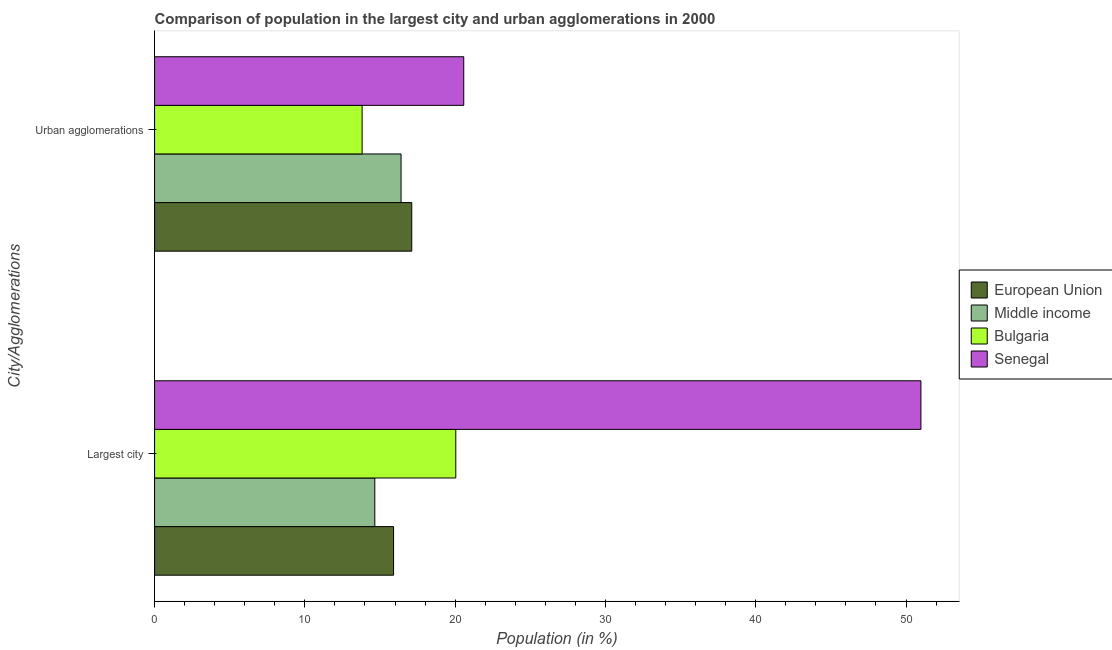How many groups of bars are there?
Make the answer very short. 2. Are the number of bars on each tick of the Y-axis equal?
Provide a short and direct response. Yes. How many bars are there on the 1st tick from the bottom?
Make the answer very short. 4. What is the label of the 2nd group of bars from the top?
Keep it short and to the point. Largest city. What is the population in the largest city in Senegal?
Provide a short and direct response. 50.99. Across all countries, what is the maximum population in the largest city?
Offer a very short reply. 50.99. Across all countries, what is the minimum population in urban agglomerations?
Provide a succinct answer. 13.81. In which country was the population in the largest city maximum?
Your answer should be compact. Senegal. In which country was the population in urban agglomerations minimum?
Give a very brief answer. Bulgaria. What is the total population in urban agglomerations in the graph?
Make the answer very short. 67.89. What is the difference between the population in urban agglomerations in Middle income and that in Bulgaria?
Give a very brief answer. 2.59. What is the difference between the population in the largest city in Middle income and the population in urban agglomerations in European Union?
Your response must be concise. -2.46. What is the average population in the largest city per country?
Make the answer very short. 25.4. What is the difference between the population in urban agglomerations and population in the largest city in Middle income?
Make the answer very short. 1.75. In how many countries, is the population in urban agglomerations greater than 34 %?
Keep it short and to the point. 0. What is the ratio of the population in the largest city in European Union to that in Middle income?
Give a very brief answer. 1.09. In how many countries, is the population in urban agglomerations greater than the average population in urban agglomerations taken over all countries?
Provide a succinct answer. 2. What does the 4th bar from the top in Largest city represents?
Offer a very short reply. European Union. What does the 1st bar from the bottom in Urban agglomerations represents?
Keep it short and to the point. European Union. How many bars are there?
Your answer should be compact. 8. How many countries are there in the graph?
Provide a short and direct response. 4. What is the difference between two consecutive major ticks on the X-axis?
Your answer should be very brief. 10. Does the graph contain any zero values?
Ensure brevity in your answer.  No. Where does the legend appear in the graph?
Give a very brief answer. Center right. How many legend labels are there?
Offer a very short reply. 4. How are the legend labels stacked?
Your answer should be very brief. Vertical. What is the title of the graph?
Your response must be concise. Comparison of population in the largest city and urban agglomerations in 2000. Does "French Polynesia" appear as one of the legend labels in the graph?
Ensure brevity in your answer.  No. What is the label or title of the Y-axis?
Offer a terse response. City/Agglomerations. What is the Population (in %) of European Union in Largest city?
Ensure brevity in your answer.  15.9. What is the Population (in %) of Middle income in Largest city?
Keep it short and to the point. 14.65. What is the Population (in %) in Bulgaria in Largest city?
Offer a very short reply. 20.04. What is the Population (in %) of Senegal in Largest city?
Provide a short and direct response. 50.99. What is the Population (in %) of European Union in Urban agglomerations?
Your answer should be very brief. 17.11. What is the Population (in %) in Middle income in Urban agglomerations?
Provide a short and direct response. 16.4. What is the Population (in %) of Bulgaria in Urban agglomerations?
Provide a short and direct response. 13.81. What is the Population (in %) in Senegal in Urban agglomerations?
Provide a short and direct response. 20.57. Across all City/Agglomerations, what is the maximum Population (in %) in European Union?
Ensure brevity in your answer.  17.11. Across all City/Agglomerations, what is the maximum Population (in %) in Middle income?
Provide a short and direct response. 16.4. Across all City/Agglomerations, what is the maximum Population (in %) in Bulgaria?
Give a very brief answer. 20.04. Across all City/Agglomerations, what is the maximum Population (in %) in Senegal?
Your response must be concise. 50.99. Across all City/Agglomerations, what is the minimum Population (in %) of European Union?
Offer a very short reply. 15.9. Across all City/Agglomerations, what is the minimum Population (in %) in Middle income?
Offer a terse response. 14.65. Across all City/Agglomerations, what is the minimum Population (in %) of Bulgaria?
Provide a short and direct response. 13.81. Across all City/Agglomerations, what is the minimum Population (in %) of Senegal?
Your response must be concise. 20.57. What is the total Population (in %) of European Union in the graph?
Provide a short and direct response. 33.02. What is the total Population (in %) of Middle income in the graph?
Make the answer very short. 31.06. What is the total Population (in %) of Bulgaria in the graph?
Your response must be concise. 33.85. What is the total Population (in %) in Senegal in the graph?
Give a very brief answer. 71.56. What is the difference between the Population (in %) in European Union in Largest city and that in Urban agglomerations?
Your answer should be compact. -1.21. What is the difference between the Population (in %) of Middle income in Largest city and that in Urban agglomerations?
Give a very brief answer. -1.75. What is the difference between the Population (in %) in Bulgaria in Largest city and that in Urban agglomerations?
Make the answer very short. 6.23. What is the difference between the Population (in %) of Senegal in Largest city and that in Urban agglomerations?
Keep it short and to the point. 30.42. What is the difference between the Population (in %) in European Union in Largest city and the Population (in %) in Middle income in Urban agglomerations?
Provide a short and direct response. -0.5. What is the difference between the Population (in %) of European Union in Largest city and the Population (in %) of Bulgaria in Urban agglomerations?
Keep it short and to the point. 2.09. What is the difference between the Population (in %) in European Union in Largest city and the Population (in %) in Senegal in Urban agglomerations?
Your answer should be very brief. -4.67. What is the difference between the Population (in %) in Middle income in Largest city and the Population (in %) in Bulgaria in Urban agglomerations?
Your response must be concise. 0.85. What is the difference between the Population (in %) in Middle income in Largest city and the Population (in %) in Senegal in Urban agglomerations?
Give a very brief answer. -5.92. What is the difference between the Population (in %) of Bulgaria in Largest city and the Population (in %) of Senegal in Urban agglomerations?
Provide a short and direct response. -0.53. What is the average Population (in %) of European Union per City/Agglomerations?
Provide a short and direct response. 16.51. What is the average Population (in %) in Middle income per City/Agglomerations?
Your response must be concise. 15.53. What is the average Population (in %) in Bulgaria per City/Agglomerations?
Your response must be concise. 16.93. What is the average Population (in %) of Senegal per City/Agglomerations?
Your answer should be compact. 35.78. What is the difference between the Population (in %) of European Union and Population (in %) of Middle income in Largest city?
Your answer should be very brief. 1.25. What is the difference between the Population (in %) of European Union and Population (in %) of Bulgaria in Largest city?
Give a very brief answer. -4.14. What is the difference between the Population (in %) of European Union and Population (in %) of Senegal in Largest city?
Provide a succinct answer. -35.09. What is the difference between the Population (in %) in Middle income and Population (in %) in Bulgaria in Largest city?
Provide a succinct answer. -5.39. What is the difference between the Population (in %) in Middle income and Population (in %) in Senegal in Largest city?
Make the answer very short. -36.34. What is the difference between the Population (in %) in Bulgaria and Population (in %) in Senegal in Largest city?
Offer a very short reply. -30.95. What is the difference between the Population (in %) in European Union and Population (in %) in Middle income in Urban agglomerations?
Make the answer very short. 0.71. What is the difference between the Population (in %) of European Union and Population (in %) of Bulgaria in Urban agglomerations?
Your response must be concise. 3.3. What is the difference between the Population (in %) of European Union and Population (in %) of Senegal in Urban agglomerations?
Offer a very short reply. -3.46. What is the difference between the Population (in %) of Middle income and Population (in %) of Bulgaria in Urban agglomerations?
Give a very brief answer. 2.59. What is the difference between the Population (in %) of Middle income and Population (in %) of Senegal in Urban agglomerations?
Keep it short and to the point. -4.17. What is the difference between the Population (in %) in Bulgaria and Population (in %) in Senegal in Urban agglomerations?
Offer a terse response. -6.76. What is the ratio of the Population (in %) of European Union in Largest city to that in Urban agglomerations?
Ensure brevity in your answer.  0.93. What is the ratio of the Population (in %) of Middle income in Largest city to that in Urban agglomerations?
Ensure brevity in your answer.  0.89. What is the ratio of the Population (in %) of Bulgaria in Largest city to that in Urban agglomerations?
Your answer should be very brief. 1.45. What is the ratio of the Population (in %) of Senegal in Largest city to that in Urban agglomerations?
Offer a terse response. 2.48. What is the difference between the highest and the second highest Population (in %) in European Union?
Offer a terse response. 1.21. What is the difference between the highest and the second highest Population (in %) in Middle income?
Offer a terse response. 1.75. What is the difference between the highest and the second highest Population (in %) in Bulgaria?
Provide a succinct answer. 6.23. What is the difference between the highest and the second highest Population (in %) in Senegal?
Your response must be concise. 30.42. What is the difference between the highest and the lowest Population (in %) in European Union?
Ensure brevity in your answer.  1.21. What is the difference between the highest and the lowest Population (in %) of Middle income?
Your response must be concise. 1.75. What is the difference between the highest and the lowest Population (in %) in Bulgaria?
Your answer should be very brief. 6.23. What is the difference between the highest and the lowest Population (in %) in Senegal?
Make the answer very short. 30.42. 